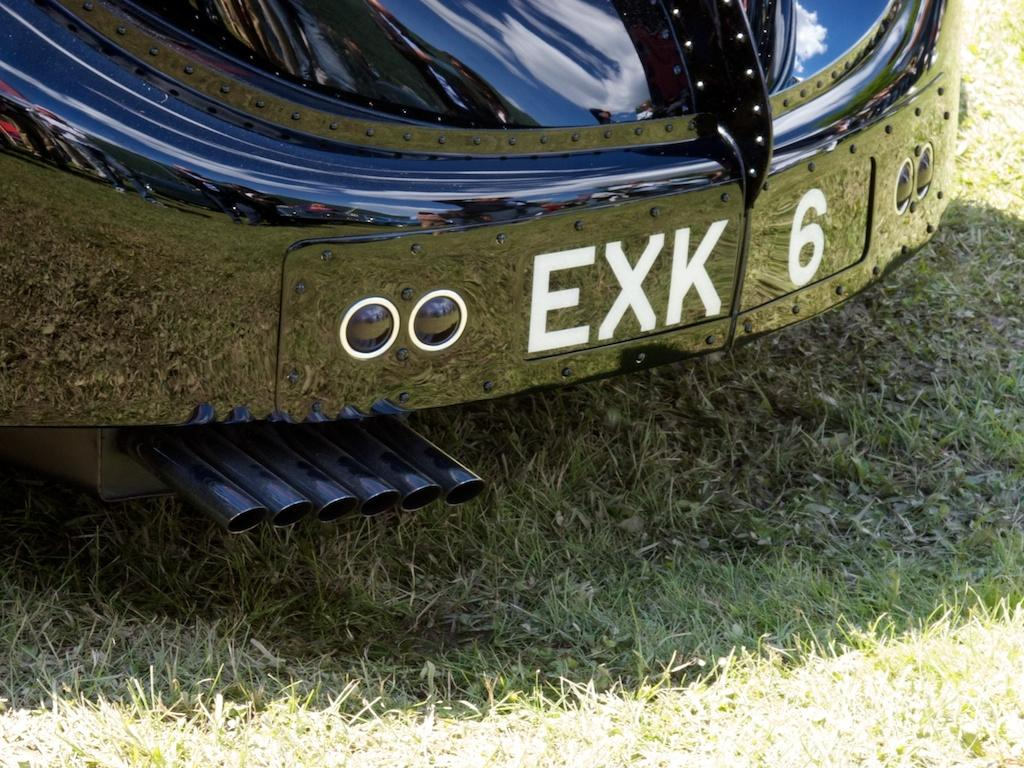What is the main subject of the image? There is a car in the image. What is the color of the car? The car is black in color. Are there any specific features on the car? Yes, there are silencers on the car. Is there any identification on the car? Yes, there is a registration plate on the car. What type of natural environment is visible in the image? There is grass visible in the image. What is the color of the grass? The grass is green in color. Can you tell me how many steps the father and son took together in the image? There is no father, son, or steps present in the image; it only features a black car with silencers, a registration plate, and green grass. 